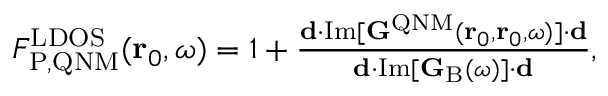Convert formula to latex. <formula><loc_0><loc_0><loc_500><loc_500>\begin{array} { r } { F _ { P , Q N M } ^ { L D O S } ( r _ { 0 } , \omega ) = 1 + \frac { d \cdot I m [ G ^ { Q N M } ( r _ { 0 } , r _ { 0 } , \omega ) ] \cdot d } { d \cdot I m [ G _ { B } ( \omega ) ] \cdot d } , } \end{array}</formula> 